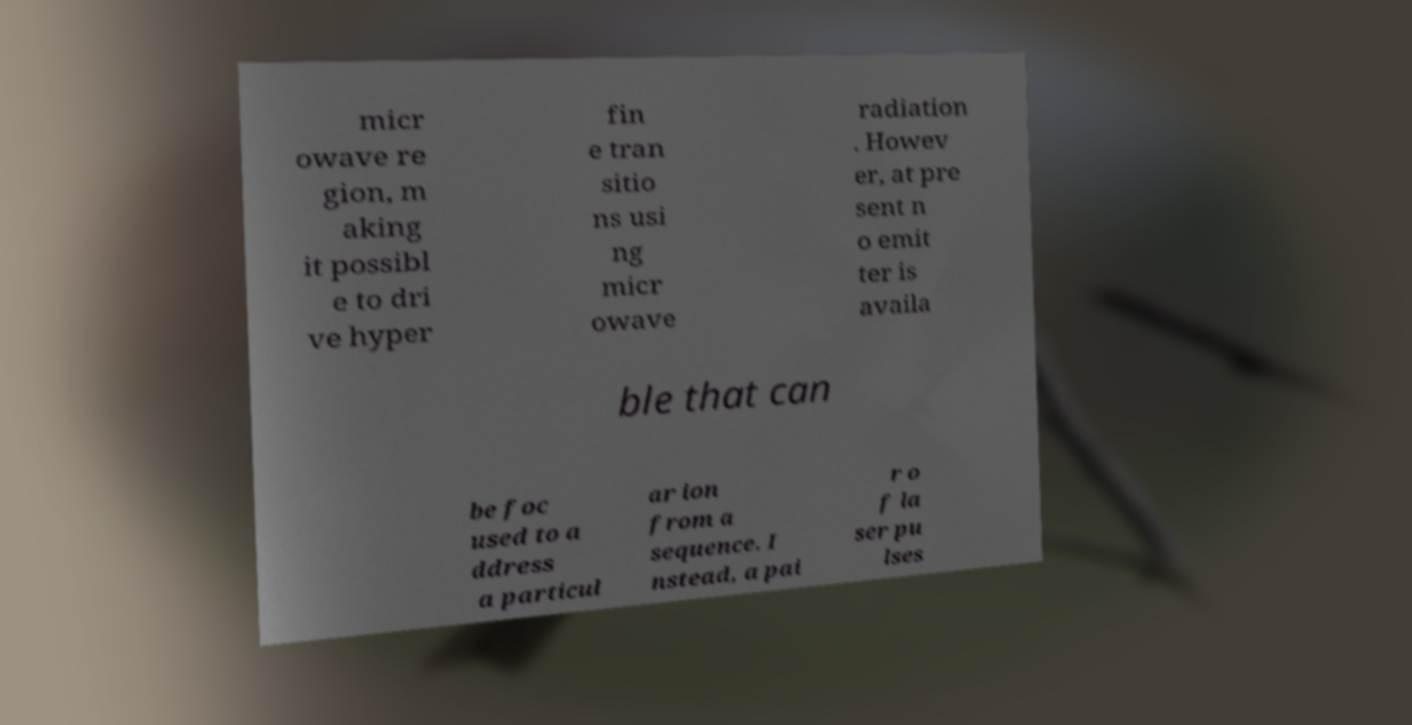I need the written content from this picture converted into text. Can you do that? micr owave re gion, m aking it possibl e to dri ve hyper fin e tran sitio ns usi ng micr owave radiation . Howev er, at pre sent n o emit ter is availa ble that can be foc used to a ddress a particul ar ion from a sequence. I nstead, a pai r o f la ser pu lses 